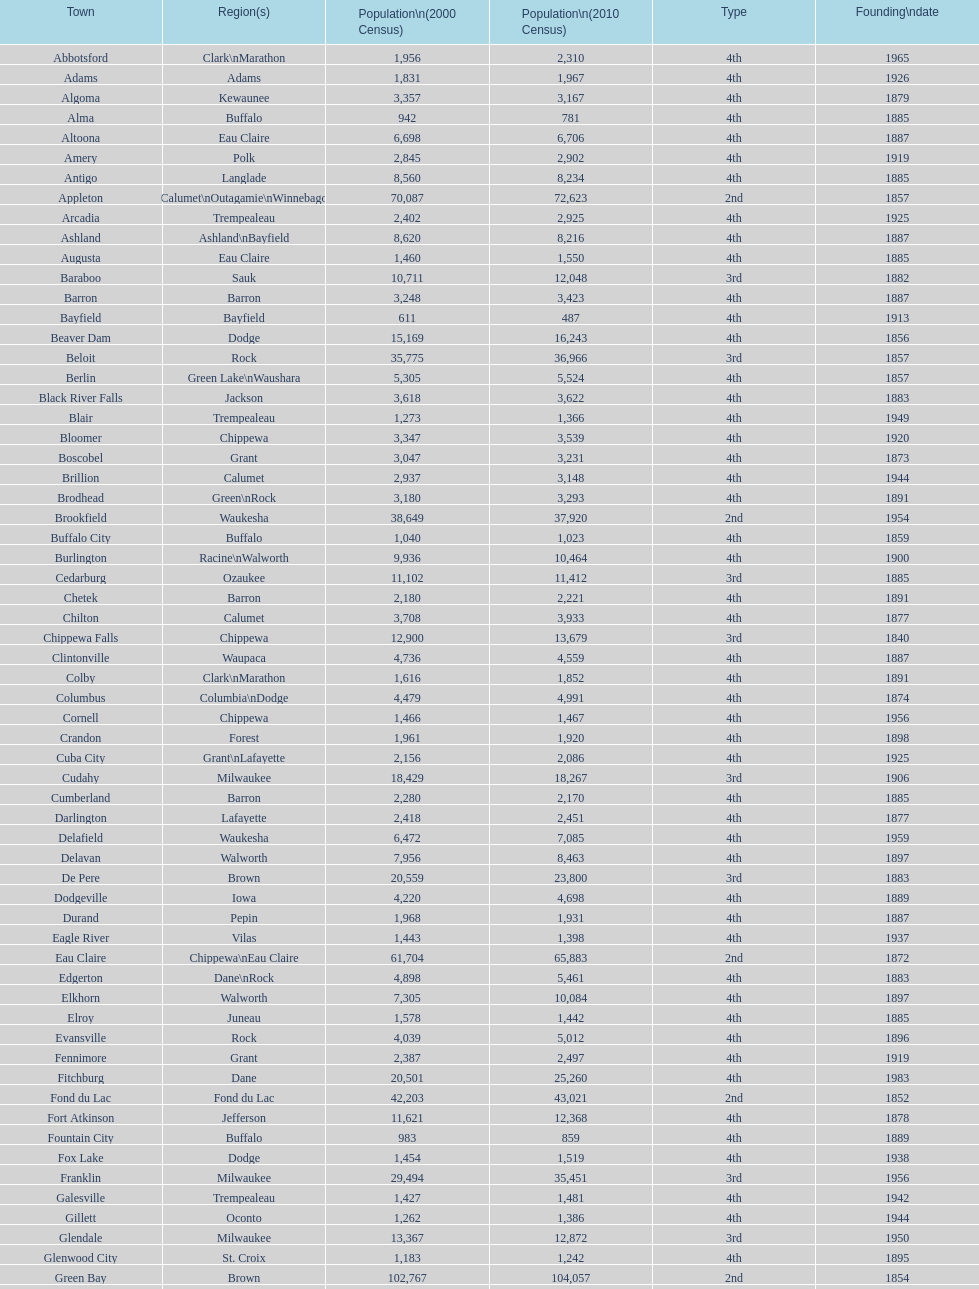What was the first city to be incorporated into wisconsin? Chippewa Falls. 